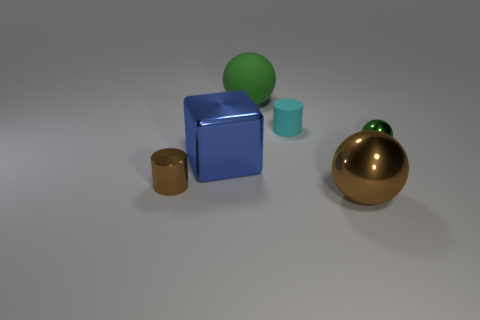Is there any other thing that has the same shape as the big blue thing?
Offer a very short reply. No. There is a object that is the same color as the small metal sphere; what is it made of?
Provide a short and direct response. Rubber. How many other things are the same shape as the tiny cyan object?
Offer a terse response. 1. Do the brown metal cylinder and the green metallic object have the same size?
Your answer should be very brief. Yes. Are any gray metallic cylinders visible?
Offer a very short reply. No. Is there a large yellow object made of the same material as the tiny green thing?
Provide a succinct answer. No. What is the material of the green sphere that is the same size as the block?
Provide a succinct answer. Rubber. How many green things have the same shape as the tiny brown metallic object?
Provide a short and direct response. 0. The brown cylinder that is the same material as the big blue object is what size?
Your response must be concise. Small. The small object that is both on the right side of the large blue shiny object and on the left side of the small green object is made of what material?
Provide a succinct answer. Rubber. 